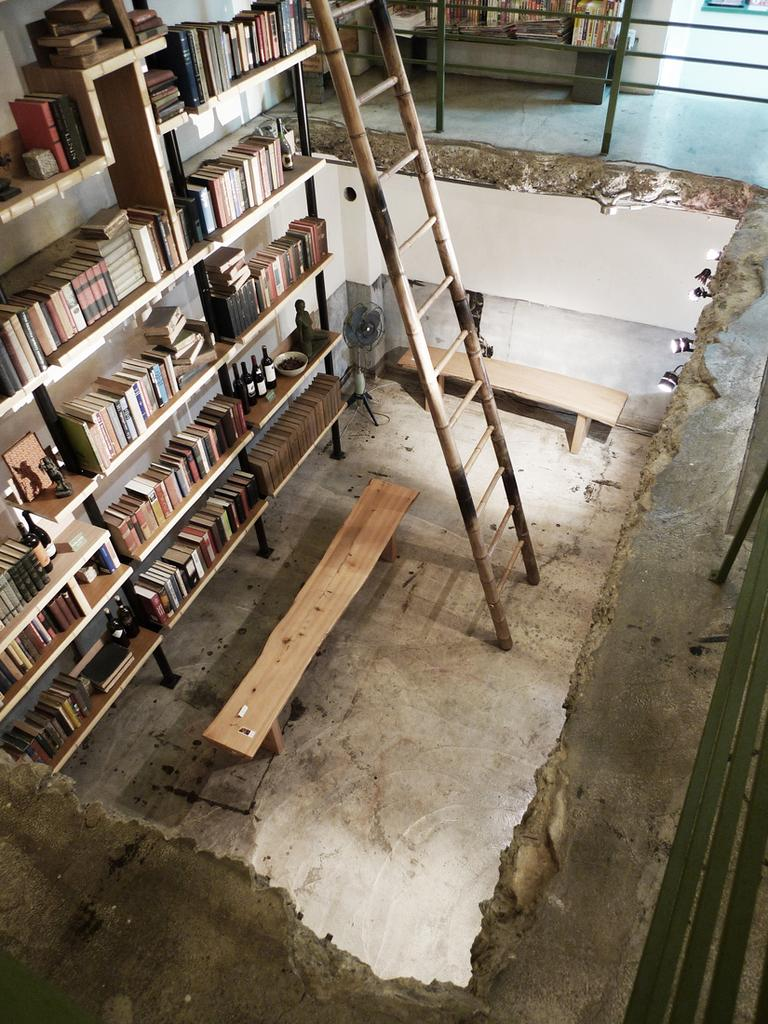What type of furniture is in the image? There is a bookshelf in the image. What is stored on the bookshelf? The bookshelf contains books. What piece of furniture is in front of the bookshelf? There is a bench in front of the bookshelf. Is there any equipment in the image that helps reach higher shelves? Yes, there is a ladder in the image. How does the bench express its feelings of hate in the image? The bench does not express any feelings in the image, as it is an inanimate object. 